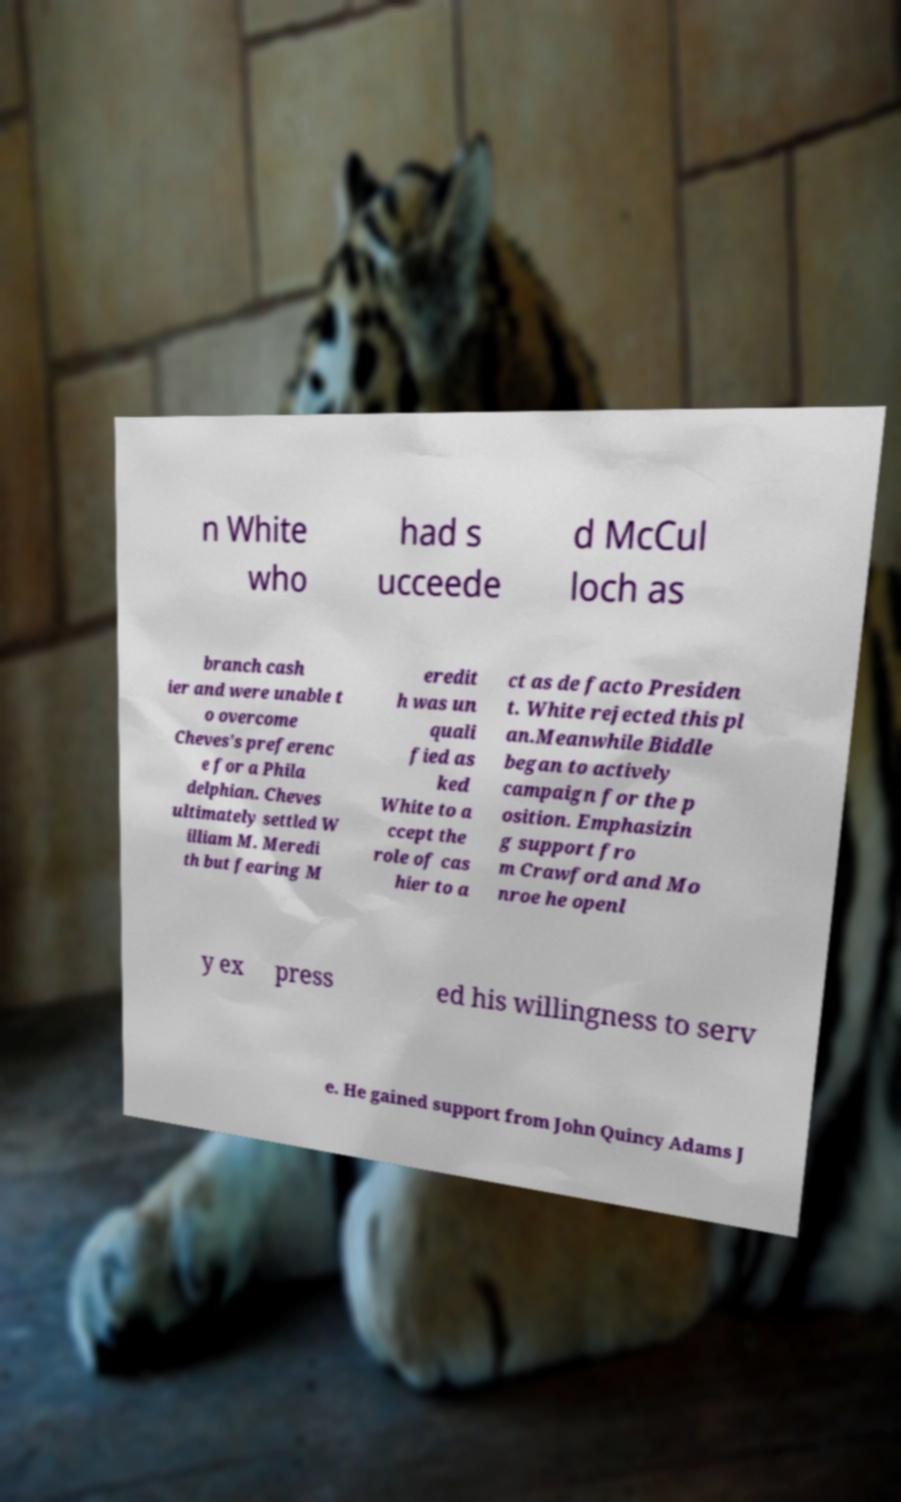I need the written content from this picture converted into text. Can you do that? n White who had s ucceede d McCul loch as branch cash ier and were unable t o overcome Cheves's preferenc e for a Phila delphian. Cheves ultimately settled W illiam M. Meredi th but fearing M eredit h was un quali fied as ked White to a ccept the role of cas hier to a ct as de facto Presiden t. White rejected this pl an.Meanwhile Biddle began to actively campaign for the p osition. Emphasizin g support fro m Crawford and Mo nroe he openl y ex press ed his willingness to serv e. He gained support from John Quincy Adams J 